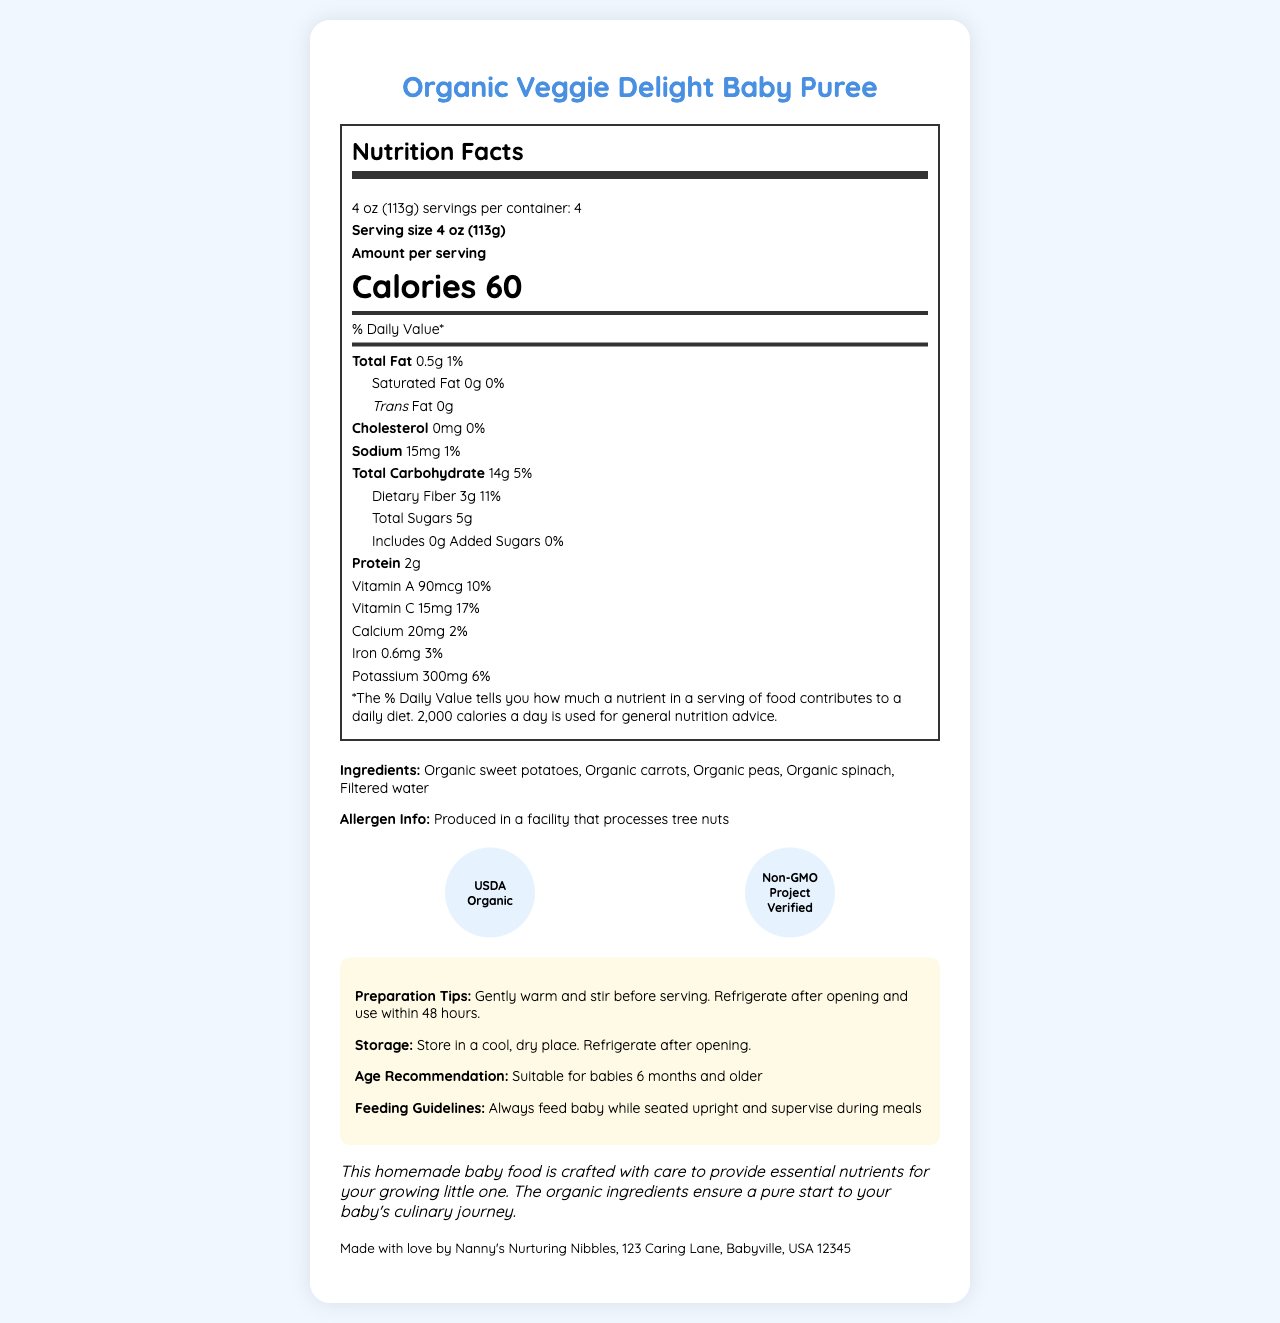how many servings per container? The Nutrition Facts Labe indicates that there are 4 servings per container.
Answer: 4 what is the serving size of the baby puree? Under the Nutrition Facts, it states that the serving size is 4 oz (113g).
Answer: 4 oz (113g) how many calories are in one serving? The Calories section mentions that each serving contains 60 calories.
Answer: 60 Is there any trans fat in the baby puree? The document states that the trans fat content is 0g.
Answer: No what are the ingredients in the Organic Veggie Delight Baby Puree? The ingredients list mentions these five components.
Answer: Organic sweet potatoes, Organic carrots, Organic peas, Organic spinach, Filtered water what percent of the daily value for Vitamin C does one serving provide? A. 10% B. 15% C. 17% D. 20% According to the Nutrition Facts, one serving provides 17% of the daily value for Vitamin C.
Answer: C. 17% what certification does this product have? A. USDA Organic B. Gluten-Free C. Non-GMO Project Verified D. All of the above The product is USDA Organic and Non-GMO Project Verified, satisfying options A and C of the question, making option D correct.
Answer: D. All of the above is the product gluten-free? The document does not mention gluten-free certification or labels.
Answer: Not enough information is any added sugar included in this baby puree? The label shows that the puree has 0g of added sugars.
Answer: No what is the recommended age for babies to consume this product? The age recommendation section states it is suitable for babies 6 months and older.
Answer: Suitable for babies 6 months and older what is the main source of carbohydrates in this baby puree according to the ingredient list? The document lists multiple vegetables as ingredients, but it does not specify the primary source of carbohydrates.
Answer: Cannot be determined does the document suggest refrigerating the puree after opening? Both the preparation tips and storage instructions indicate that the puree should be refrigerated after opening.
Answer: Yes summarize the entire document The document includes comprehensive nutritional information, ingredient details, preparation and storage tips, and consumption guidelines, emphasizing the homemade, organic nature of the baby food.
Answer: The document presents the Nutrition Facts for Organic Veggie Delight Baby Puree. It includes information on serving size, calorie count, and nutrient breakdown, such as total fat, cholesterol, sodium, carbohydrates, dietary fiber, sugars, and protein. Additionally, it lists the vitamins and minerals contained in it. The document also features details on ingredients, allergen information, certifications, preparation tips, storage instructions, and the target age for consumption. The puree is made by Nanny's Nurturing Nibbles, and it is suitable for babies 6 months and older, with feeding guidelines provided. 